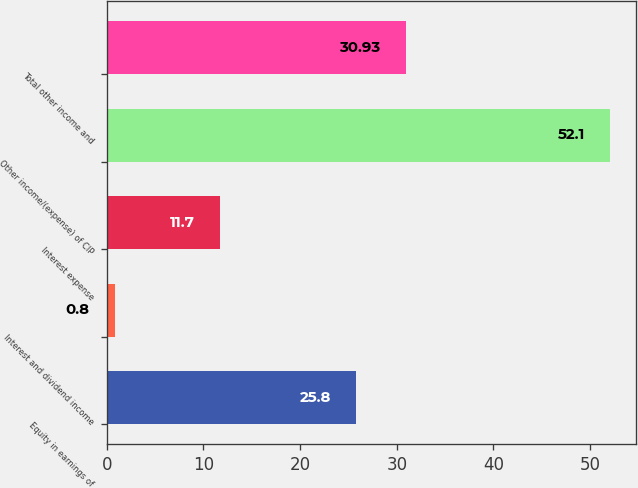Convert chart. <chart><loc_0><loc_0><loc_500><loc_500><bar_chart><fcel>Equity in earnings of<fcel>Interest and dividend income<fcel>Interest expense<fcel>Other income/(expense) of CIP<fcel>Total other income and<nl><fcel>25.8<fcel>0.8<fcel>11.7<fcel>52.1<fcel>30.93<nl></chart> 